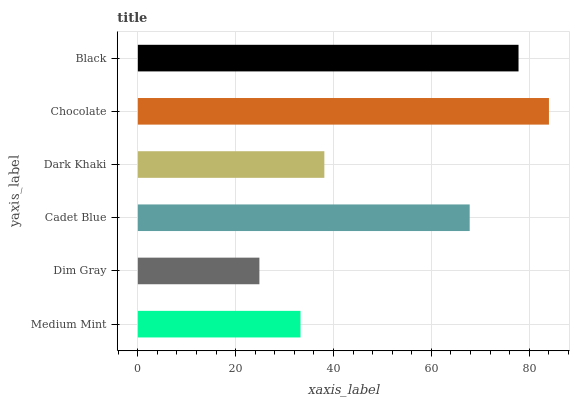Is Dim Gray the minimum?
Answer yes or no. Yes. Is Chocolate the maximum?
Answer yes or no. Yes. Is Cadet Blue the minimum?
Answer yes or no. No. Is Cadet Blue the maximum?
Answer yes or no. No. Is Cadet Blue greater than Dim Gray?
Answer yes or no. Yes. Is Dim Gray less than Cadet Blue?
Answer yes or no. Yes. Is Dim Gray greater than Cadet Blue?
Answer yes or no. No. Is Cadet Blue less than Dim Gray?
Answer yes or no. No. Is Cadet Blue the high median?
Answer yes or no. Yes. Is Dark Khaki the low median?
Answer yes or no. Yes. Is Black the high median?
Answer yes or no. No. Is Dim Gray the low median?
Answer yes or no. No. 